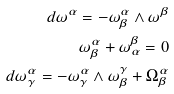Convert formula to latex. <formula><loc_0><loc_0><loc_500><loc_500>d \omega ^ { \alpha } = - \omega ^ { \alpha } _ { \beta } \wedge \omega ^ { \beta } \\ \omega _ { \beta } ^ { \alpha } + \omega _ { \alpha } ^ { \beta } = 0 \\ d \omega ^ { \alpha } _ { \gamma } = - \omega ^ { \alpha } _ { \gamma } \wedge \omega ^ { \gamma } _ { \beta } + \Omega _ { \beta } ^ { \alpha }</formula> 